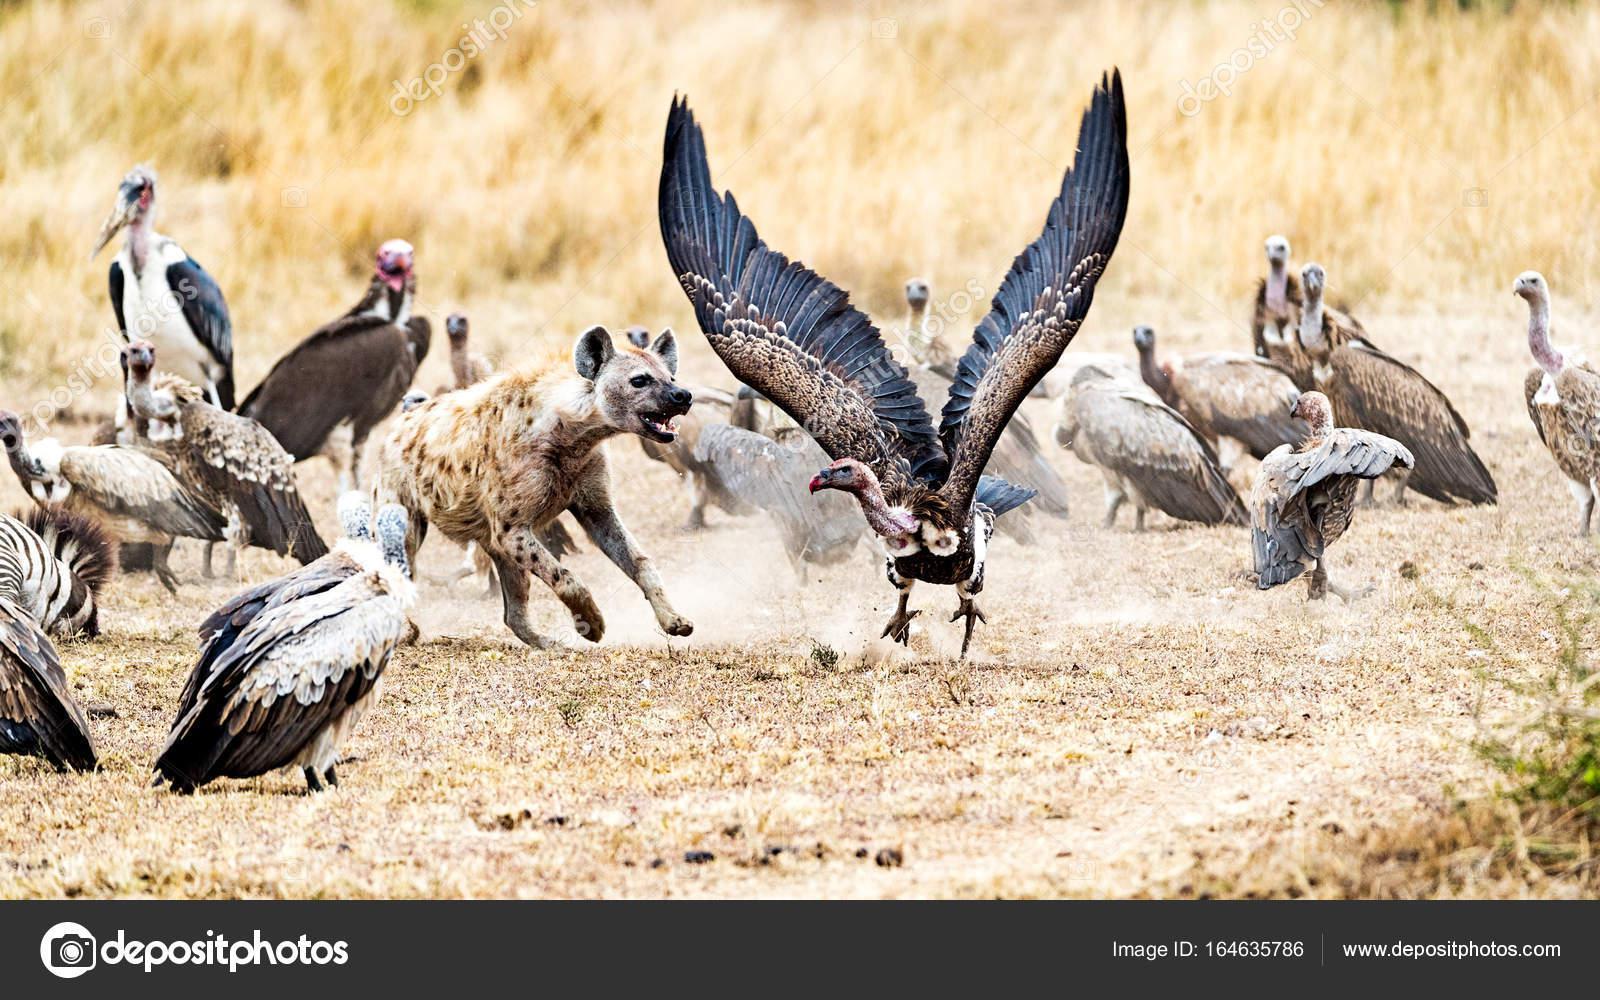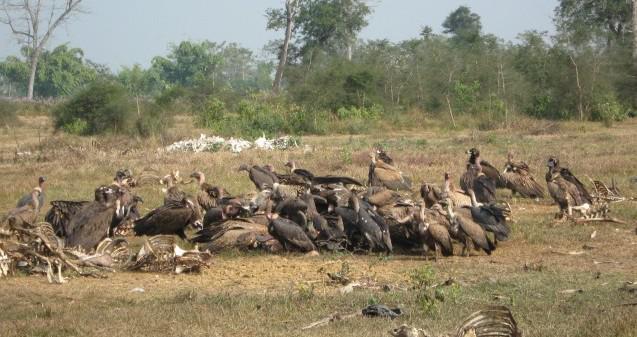The first image is the image on the left, the second image is the image on the right. For the images displayed, is the sentence "One image shows exactly two vultures in a nest of sticks and leaves, and the other image shows several vultures perched on leafless branches." factually correct? Answer yes or no. No. The first image is the image on the left, the second image is the image on the right. Analyze the images presented: Is the assertion "Birds are sitting on tree branches in both images." valid? Answer yes or no. No. 